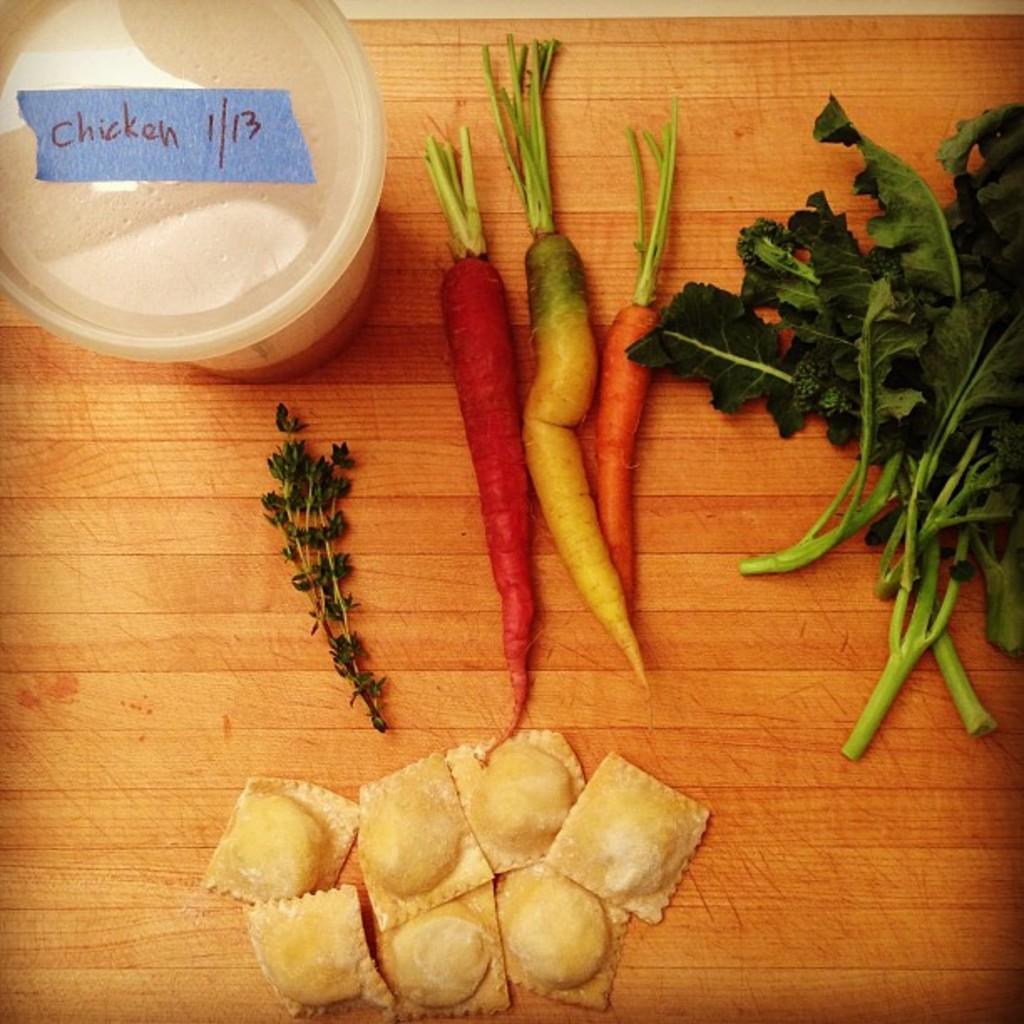Please provide a concise description of this image. In this picture we can observe vegetables like carrot and leafy vegetables. We can observe some food and a box placed on the brown color table. 